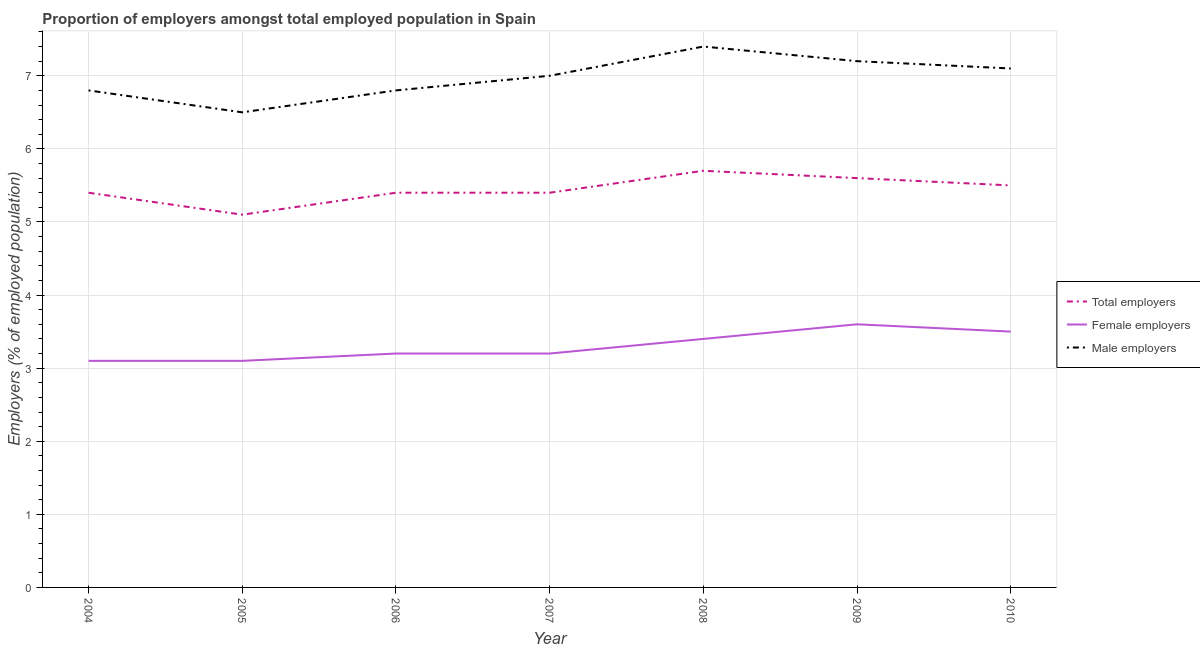Is the number of lines equal to the number of legend labels?
Give a very brief answer. Yes. What is the percentage of female employers in 2007?
Offer a very short reply. 3.2. Across all years, what is the maximum percentage of female employers?
Make the answer very short. 3.6. In which year was the percentage of female employers maximum?
Provide a short and direct response. 2009. What is the total percentage of total employers in the graph?
Provide a short and direct response. 38.1. What is the difference between the percentage of total employers in 2006 and that in 2008?
Your response must be concise. -0.3. What is the difference between the percentage of female employers in 2006 and the percentage of male employers in 2005?
Make the answer very short. -3.3. What is the average percentage of male employers per year?
Provide a succinct answer. 6.97. In the year 2006, what is the difference between the percentage of female employers and percentage of male employers?
Your answer should be very brief. -3.6. What is the ratio of the percentage of female employers in 2005 to that in 2006?
Your answer should be compact. 0.97. Is the difference between the percentage of total employers in 2006 and 2007 greater than the difference between the percentage of female employers in 2006 and 2007?
Your answer should be very brief. No. What is the difference between the highest and the second highest percentage of female employers?
Keep it short and to the point. 0.1. What is the difference between the highest and the lowest percentage of total employers?
Offer a terse response. 0.6. In how many years, is the percentage of total employers greater than the average percentage of total employers taken over all years?
Provide a succinct answer. 3. Is the sum of the percentage of female employers in 2009 and 2010 greater than the maximum percentage of total employers across all years?
Provide a short and direct response. Yes. Does the percentage of male employers monotonically increase over the years?
Make the answer very short. No. Is the percentage of total employers strictly less than the percentage of female employers over the years?
Offer a very short reply. No. How many years are there in the graph?
Offer a terse response. 7. Does the graph contain grids?
Provide a succinct answer. Yes. Where does the legend appear in the graph?
Keep it short and to the point. Center right. What is the title of the graph?
Provide a short and direct response. Proportion of employers amongst total employed population in Spain. Does "Ages 20-60" appear as one of the legend labels in the graph?
Your answer should be compact. No. What is the label or title of the Y-axis?
Offer a very short reply. Employers (% of employed population). What is the Employers (% of employed population) of Total employers in 2004?
Make the answer very short. 5.4. What is the Employers (% of employed population) of Female employers in 2004?
Your response must be concise. 3.1. What is the Employers (% of employed population) in Male employers in 2004?
Ensure brevity in your answer.  6.8. What is the Employers (% of employed population) in Total employers in 2005?
Offer a terse response. 5.1. What is the Employers (% of employed population) in Female employers in 2005?
Offer a very short reply. 3.1. What is the Employers (% of employed population) in Male employers in 2005?
Your response must be concise. 6.5. What is the Employers (% of employed population) in Total employers in 2006?
Keep it short and to the point. 5.4. What is the Employers (% of employed population) of Female employers in 2006?
Provide a succinct answer. 3.2. What is the Employers (% of employed population) of Male employers in 2006?
Keep it short and to the point. 6.8. What is the Employers (% of employed population) of Total employers in 2007?
Offer a terse response. 5.4. What is the Employers (% of employed population) of Female employers in 2007?
Your answer should be very brief. 3.2. What is the Employers (% of employed population) of Total employers in 2008?
Make the answer very short. 5.7. What is the Employers (% of employed population) of Female employers in 2008?
Offer a terse response. 3.4. What is the Employers (% of employed population) of Male employers in 2008?
Your answer should be very brief. 7.4. What is the Employers (% of employed population) in Total employers in 2009?
Offer a very short reply. 5.6. What is the Employers (% of employed population) in Female employers in 2009?
Ensure brevity in your answer.  3.6. What is the Employers (% of employed population) of Male employers in 2009?
Make the answer very short. 7.2. What is the Employers (% of employed population) in Female employers in 2010?
Ensure brevity in your answer.  3.5. What is the Employers (% of employed population) in Male employers in 2010?
Offer a very short reply. 7.1. Across all years, what is the maximum Employers (% of employed population) of Total employers?
Provide a short and direct response. 5.7. Across all years, what is the maximum Employers (% of employed population) of Female employers?
Make the answer very short. 3.6. Across all years, what is the maximum Employers (% of employed population) of Male employers?
Provide a short and direct response. 7.4. Across all years, what is the minimum Employers (% of employed population) in Total employers?
Provide a short and direct response. 5.1. Across all years, what is the minimum Employers (% of employed population) in Female employers?
Your response must be concise. 3.1. What is the total Employers (% of employed population) of Total employers in the graph?
Ensure brevity in your answer.  38.1. What is the total Employers (% of employed population) in Female employers in the graph?
Offer a very short reply. 23.1. What is the total Employers (% of employed population) in Male employers in the graph?
Ensure brevity in your answer.  48.8. What is the difference between the Employers (% of employed population) in Total employers in 2004 and that in 2005?
Ensure brevity in your answer.  0.3. What is the difference between the Employers (% of employed population) in Female employers in 2004 and that in 2005?
Keep it short and to the point. 0. What is the difference between the Employers (% of employed population) in Female employers in 2004 and that in 2006?
Provide a short and direct response. -0.1. What is the difference between the Employers (% of employed population) of Total employers in 2004 and that in 2007?
Make the answer very short. 0. What is the difference between the Employers (% of employed population) in Male employers in 2004 and that in 2007?
Make the answer very short. -0.2. What is the difference between the Employers (% of employed population) of Male employers in 2004 and that in 2008?
Your answer should be compact. -0.6. What is the difference between the Employers (% of employed population) of Female employers in 2004 and that in 2009?
Make the answer very short. -0.5. What is the difference between the Employers (% of employed population) of Male employers in 2004 and that in 2009?
Ensure brevity in your answer.  -0.4. What is the difference between the Employers (% of employed population) in Female employers in 2004 and that in 2010?
Your response must be concise. -0.4. What is the difference between the Employers (% of employed population) of Male employers in 2004 and that in 2010?
Your answer should be compact. -0.3. What is the difference between the Employers (% of employed population) of Female employers in 2005 and that in 2006?
Provide a short and direct response. -0.1. What is the difference between the Employers (% of employed population) of Male employers in 2005 and that in 2006?
Provide a succinct answer. -0.3. What is the difference between the Employers (% of employed population) in Female employers in 2005 and that in 2007?
Keep it short and to the point. -0.1. What is the difference between the Employers (% of employed population) of Total employers in 2005 and that in 2008?
Your answer should be very brief. -0.6. What is the difference between the Employers (% of employed population) of Female employers in 2005 and that in 2008?
Make the answer very short. -0.3. What is the difference between the Employers (% of employed population) in Female employers in 2005 and that in 2009?
Provide a succinct answer. -0.5. What is the difference between the Employers (% of employed population) in Female employers in 2005 and that in 2010?
Offer a terse response. -0.4. What is the difference between the Employers (% of employed population) of Total employers in 2006 and that in 2007?
Ensure brevity in your answer.  0. What is the difference between the Employers (% of employed population) of Male employers in 2006 and that in 2007?
Your answer should be compact. -0.2. What is the difference between the Employers (% of employed population) in Female employers in 2006 and that in 2008?
Offer a very short reply. -0.2. What is the difference between the Employers (% of employed population) in Female employers in 2006 and that in 2009?
Give a very brief answer. -0.4. What is the difference between the Employers (% of employed population) in Total employers in 2006 and that in 2010?
Your answer should be compact. -0.1. What is the difference between the Employers (% of employed population) in Female employers in 2006 and that in 2010?
Make the answer very short. -0.3. What is the difference between the Employers (% of employed population) in Male employers in 2006 and that in 2010?
Provide a short and direct response. -0.3. What is the difference between the Employers (% of employed population) in Total employers in 2007 and that in 2008?
Your answer should be compact. -0.3. What is the difference between the Employers (% of employed population) of Male employers in 2007 and that in 2008?
Ensure brevity in your answer.  -0.4. What is the difference between the Employers (% of employed population) in Male employers in 2007 and that in 2009?
Offer a terse response. -0.2. What is the difference between the Employers (% of employed population) in Female employers in 2007 and that in 2010?
Your answer should be compact. -0.3. What is the difference between the Employers (% of employed population) of Total employers in 2008 and that in 2009?
Keep it short and to the point. 0.1. What is the difference between the Employers (% of employed population) in Total employers in 2008 and that in 2010?
Offer a terse response. 0.2. What is the difference between the Employers (% of employed population) of Male employers in 2008 and that in 2010?
Make the answer very short. 0.3. What is the difference between the Employers (% of employed population) of Male employers in 2009 and that in 2010?
Your answer should be compact. 0.1. What is the difference between the Employers (% of employed population) in Total employers in 2004 and the Employers (% of employed population) in Female employers in 2005?
Your answer should be compact. 2.3. What is the difference between the Employers (% of employed population) in Total employers in 2004 and the Employers (% of employed population) in Male employers in 2005?
Offer a very short reply. -1.1. What is the difference between the Employers (% of employed population) in Total employers in 2004 and the Employers (% of employed population) in Male employers in 2006?
Ensure brevity in your answer.  -1.4. What is the difference between the Employers (% of employed population) of Total employers in 2004 and the Employers (% of employed population) of Female employers in 2007?
Provide a short and direct response. 2.2. What is the difference between the Employers (% of employed population) in Total employers in 2004 and the Employers (% of employed population) in Male employers in 2008?
Keep it short and to the point. -2. What is the difference between the Employers (% of employed population) of Female employers in 2004 and the Employers (% of employed population) of Male employers in 2008?
Your answer should be very brief. -4.3. What is the difference between the Employers (% of employed population) in Total employers in 2004 and the Employers (% of employed population) in Female employers in 2009?
Provide a short and direct response. 1.8. What is the difference between the Employers (% of employed population) of Total employers in 2004 and the Employers (% of employed population) of Female employers in 2010?
Provide a succinct answer. 1.9. What is the difference between the Employers (% of employed population) of Total employers in 2004 and the Employers (% of employed population) of Male employers in 2010?
Your response must be concise. -1.7. What is the difference between the Employers (% of employed population) in Female employers in 2004 and the Employers (% of employed population) in Male employers in 2010?
Make the answer very short. -4. What is the difference between the Employers (% of employed population) of Total employers in 2005 and the Employers (% of employed population) of Female employers in 2006?
Offer a very short reply. 1.9. What is the difference between the Employers (% of employed population) in Total employers in 2005 and the Employers (% of employed population) in Male employers in 2006?
Your response must be concise. -1.7. What is the difference between the Employers (% of employed population) in Total employers in 2005 and the Employers (% of employed population) in Male employers in 2007?
Your response must be concise. -1.9. What is the difference between the Employers (% of employed population) of Total employers in 2005 and the Employers (% of employed population) of Female employers in 2008?
Provide a short and direct response. 1.7. What is the difference between the Employers (% of employed population) of Total employers in 2005 and the Employers (% of employed population) of Male employers in 2008?
Provide a short and direct response. -2.3. What is the difference between the Employers (% of employed population) in Female employers in 2005 and the Employers (% of employed population) in Male employers in 2008?
Provide a short and direct response. -4.3. What is the difference between the Employers (% of employed population) in Total employers in 2005 and the Employers (% of employed population) in Male employers in 2010?
Make the answer very short. -2. What is the difference between the Employers (% of employed population) in Total employers in 2006 and the Employers (% of employed population) in Male employers in 2008?
Your answer should be compact. -2. What is the difference between the Employers (% of employed population) in Female employers in 2006 and the Employers (% of employed population) in Male employers in 2009?
Ensure brevity in your answer.  -4. What is the difference between the Employers (% of employed population) of Total employers in 2006 and the Employers (% of employed population) of Male employers in 2010?
Keep it short and to the point. -1.7. What is the difference between the Employers (% of employed population) in Female employers in 2006 and the Employers (% of employed population) in Male employers in 2010?
Your response must be concise. -3.9. What is the difference between the Employers (% of employed population) in Total employers in 2007 and the Employers (% of employed population) in Female employers in 2009?
Your response must be concise. 1.8. What is the difference between the Employers (% of employed population) in Total employers in 2007 and the Employers (% of employed population) in Male employers in 2009?
Keep it short and to the point. -1.8. What is the difference between the Employers (% of employed population) in Total employers in 2008 and the Employers (% of employed population) in Female employers in 2010?
Offer a very short reply. 2.2. What is the difference between the Employers (% of employed population) of Total employers in 2008 and the Employers (% of employed population) of Male employers in 2010?
Ensure brevity in your answer.  -1.4. What is the difference between the Employers (% of employed population) of Total employers in 2009 and the Employers (% of employed population) of Male employers in 2010?
Ensure brevity in your answer.  -1.5. What is the difference between the Employers (% of employed population) of Female employers in 2009 and the Employers (% of employed population) of Male employers in 2010?
Make the answer very short. -3.5. What is the average Employers (% of employed population) of Total employers per year?
Your answer should be compact. 5.44. What is the average Employers (% of employed population) in Female employers per year?
Your response must be concise. 3.3. What is the average Employers (% of employed population) of Male employers per year?
Provide a succinct answer. 6.97. In the year 2004, what is the difference between the Employers (% of employed population) in Total employers and Employers (% of employed population) in Male employers?
Provide a short and direct response. -1.4. In the year 2005, what is the difference between the Employers (% of employed population) of Total employers and Employers (% of employed population) of Female employers?
Your answer should be very brief. 2. In the year 2005, what is the difference between the Employers (% of employed population) in Total employers and Employers (% of employed population) in Male employers?
Keep it short and to the point. -1.4. In the year 2005, what is the difference between the Employers (% of employed population) of Female employers and Employers (% of employed population) of Male employers?
Give a very brief answer. -3.4. In the year 2006, what is the difference between the Employers (% of employed population) of Total employers and Employers (% of employed population) of Female employers?
Offer a very short reply. 2.2. In the year 2006, what is the difference between the Employers (% of employed population) in Total employers and Employers (% of employed population) in Male employers?
Offer a terse response. -1.4. In the year 2008, what is the difference between the Employers (% of employed population) in Total employers and Employers (% of employed population) in Female employers?
Provide a short and direct response. 2.3. In the year 2009, what is the difference between the Employers (% of employed population) in Total employers and Employers (% of employed population) in Female employers?
Offer a very short reply. 2. In the year 2010, what is the difference between the Employers (% of employed population) in Total employers and Employers (% of employed population) in Female employers?
Make the answer very short. 2. In the year 2010, what is the difference between the Employers (% of employed population) of Female employers and Employers (% of employed population) of Male employers?
Ensure brevity in your answer.  -3.6. What is the ratio of the Employers (% of employed population) of Total employers in 2004 to that in 2005?
Offer a very short reply. 1.06. What is the ratio of the Employers (% of employed population) in Male employers in 2004 to that in 2005?
Make the answer very short. 1.05. What is the ratio of the Employers (% of employed population) in Female employers in 2004 to that in 2006?
Your answer should be very brief. 0.97. What is the ratio of the Employers (% of employed population) in Male employers in 2004 to that in 2006?
Offer a very short reply. 1. What is the ratio of the Employers (% of employed population) in Total employers in 2004 to that in 2007?
Make the answer very short. 1. What is the ratio of the Employers (% of employed population) of Female employers in 2004 to that in 2007?
Keep it short and to the point. 0.97. What is the ratio of the Employers (% of employed population) in Male employers in 2004 to that in 2007?
Provide a short and direct response. 0.97. What is the ratio of the Employers (% of employed population) of Total employers in 2004 to that in 2008?
Provide a short and direct response. 0.95. What is the ratio of the Employers (% of employed population) in Female employers in 2004 to that in 2008?
Provide a succinct answer. 0.91. What is the ratio of the Employers (% of employed population) in Male employers in 2004 to that in 2008?
Make the answer very short. 0.92. What is the ratio of the Employers (% of employed population) of Total employers in 2004 to that in 2009?
Your answer should be very brief. 0.96. What is the ratio of the Employers (% of employed population) of Female employers in 2004 to that in 2009?
Provide a succinct answer. 0.86. What is the ratio of the Employers (% of employed population) in Total employers in 2004 to that in 2010?
Make the answer very short. 0.98. What is the ratio of the Employers (% of employed population) in Female employers in 2004 to that in 2010?
Your answer should be very brief. 0.89. What is the ratio of the Employers (% of employed population) of Male employers in 2004 to that in 2010?
Keep it short and to the point. 0.96. What is the ratio of the Employers (% of employed population) in Female employers in 2005 to that in 2006?
Your answer should be compact. 0.97. What is the ratio of the Employers (% of employed population) of Male employers in 2005 to that in 2006?
Offer a very short reply. 0.96. What is the ratio of the Employers (% of employed population) in Total employers in 2005 to that in 2007?
Ensure brevity in your answer.  0.94. What is the ratio of the Employers (% of employed population) in Female employers in 2005 to that in 2007?
Offer a very short reply. 0.97. What is the ratio of the Employers (% of employed population) in Total employers in 2005 to that in 2008?
Your response must be concise. 0.89. What is the ratio of the Employers (% of employed population) of Female employers in 2005 to that in 2008?
Provide a succinct answer. 0.91. What is the ratio of the Employers (% of employed population) of Male employers in 2005 to that in 2008?
Provide a short and direct response. 0.88. What is the ratio of the Employers (% of employed population) of Total employers in 2005 to that in 2009?
Provide a short and direct response. 0.91. What is the ratio of the Employers (% of employed population) of Female employers in 2005 to that in 2009?
Provide a succinct answer. 0.86. What is the ratio of the Employers (% of employed population) of Male employers in 2005 to that in 2009?
Your answer should be compact. 0.9. What is the ratio of the Employers (% of employed population) in Total employers in 2005 to that in 2010?
Keep it short and to the point. 0.93. What is the ratio of the Employers (% of employed population) of Female employers in 2005 to that in 2010?
Your answer should be very brief. 0.89. What is the ratio of the Employers (% of employed population) in Male employers in 2005 to that in 2010?
Provide a succinct answer. 0.92. What is the ratio of the Employers (% of employed population) in Male employers in 2006 to that in 2007?
Offer a terse response. 0.97. What is the ratio of the Employers (% of employed population) of Total employers in 2006 to that in 2008?
Make the answer very short. 0.95. What is the ratio of the Employers (% of employed population) in Female employers in 2006 to that in 2008?
Offer a very short reply. 0.94. What is the ratio of the Employers (% of employed population) of Male employers in 2006 to that in 2008?
Make the answer very short. 0.92. What is the ratio of the Employers (% of employed population) of Female employers in 2006 to that in 2009?
Offer a very short reply. 0.89. What is the ratio of the Employers (% of employed population) of Male employers in 2006 to that in 2009?
Your response must be concise. 0.94. What is the ratio of the Employers (% of employed population) of Total employers in 2006 to that in 2010?
Offer a terse response. 0.98. What is the ratio of the Employers (% of employed population) of Female employers in 2006 to that in 2010?
Make the answer very short. 0.91. What is the ratio of the Employers (% of employed population) of Male employers in 2006 to that in 2010?
Your answer should be compact. 0.96. What is the ratio of the Employers (% of employed population) in Total employers in 2007 to that in 2008?
Your answer should be compact. 0.95. What is the ratio of the Employers (% of employed population) of Male employers in 2007 to that in 2008?
Offer a terse response. 0.95. What is the ratio of the Employers (% of employed population) of Female employers in 2007 to that in 2009?
Provide a short and direct response. 0.89. What is the ratio of the Employers (% of employed population) in Male employers in 2007 to that in 2009?
Provide a succinct answer. 0.97. What is the ratio of the Employers (% of employed population) in Total employers in 2007 to that in 2010?
Keep it short and to the point. 0.98. What is the ratio of the Employers (% of employed population) of Female employers in 2007 to that in 2010?
Make the answer very short. 0.91. What is the ratio of the Employers (% of employed population) in Male employers in 2007 to that in 2010?
Your answer should be compact. 0.99. What is the ratio of the Employers (% of employed population) in Total employers in 2008 to that in 2009?
Provide a short and direct response. 1.02. What is the ratio of the Employers (% of employed population) in Male employers in 2008 to that in 2009?
Offer a terse response. 1.03. What is the ratio of the Employers (% of employed population) in Total employers in 2008 to that in 2010?
Give a very brief answer. 1.04. What is the ratio of the Employers (% of employed population) of Female employers in 2008 to that in 2010?
Your response must be concise. 0.97. What is the ratio of the Employers (% of employed population) in Male employers in 2008 to that in 2010?
Provide a short and direct response. 1.04. What is the ratio of the Employers (% of employed population) in Total employers in 2009 to that in 2010?
Keep it short and to the point. 1.02. What is the ratio of the Employers (% of employed population) of Female employers in 2009 to that in 2010?
Make the answer very short. 1.03. What is the ratio of the Employers (% of employed population) of Male employers in 2009 to that in 2010?
Your answer should be compact. 1.01. What is the difference between the highest and the second highest Employers (% of employed population) of Female employers?
Ensure brevity in your answer.  0.1. What is the difference between the highest and the second highest Employers (% of employed population) of Male employers?
Ensure brevity in your answer.  0.2. What is the difference between the highest and the lowest Employers (% of employed population) in Female employers?
Your answer should be compact. 0.5. What is the difference between the highest and the lowest Employers (% of employed population) in Male employers?
Ensure brevity in your answer.  0.9. 